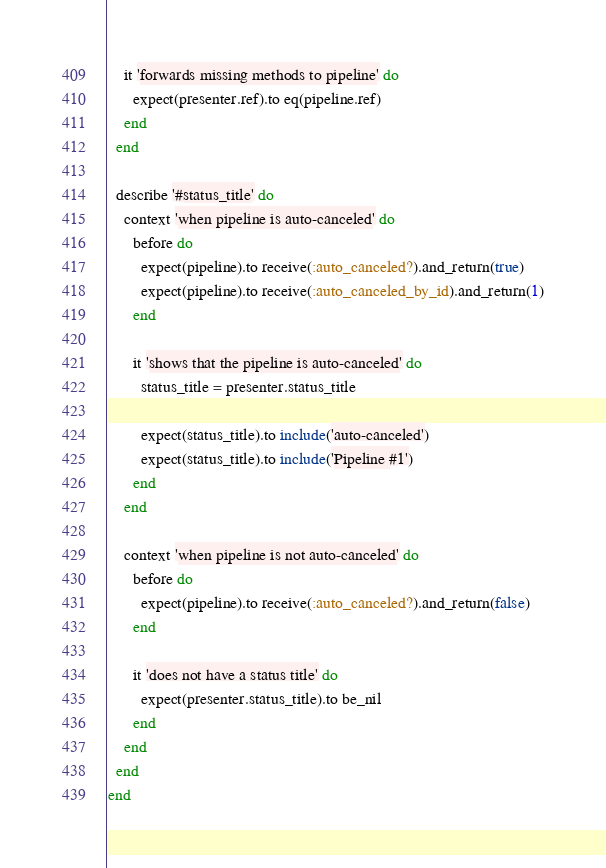Convert code to text. <code><loc_0><loc_0><loc_500><loc_500><_Ruby_>    it 'forwards missing methods to pipeline' do
      expect(presenter.ref).to eq(pipeline.ref)
    end
  end

  describe '#status_title' do
    context 'when pipeline is auto-canceled' do
      before do
        expect(pipeline).to receive(:auto_canceled?).and_return(true)
        expect(pipeline).to receive(:auto_canceled_by_id).and_return(1)
      end

      it 'shows that the pipeline is auto-canceled' do
        status_title = presenter.status_title

        expect(status_title).to include('auto-canceled')
        expect(status_title).to include('Pipeline #1')
      end
    end

    context 'when pipeline is not auto-canceled' do
      before do
        expect(pipeline).to receive(:auto_canceled?).and_return(false)
      end

      it 'does not have a status title' do
        expect(presenter.status_title).to be_nil
      end
    end
  end
end
</code> 